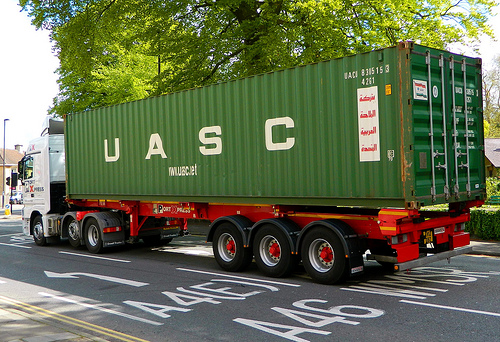Which kind of furniture is red? The red piece of furniture is a bed. 